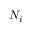<formula> <loc_0><loc_0><loc_500><loc_500>N _ { i }</formula> 